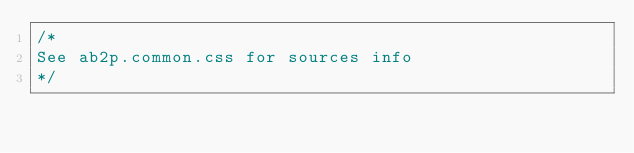Convert code to text. <code><loc_0><loc_0><loc_500><loc_500><_CSS_>/*
See ab2p.common.css for sources info
*/</code> 